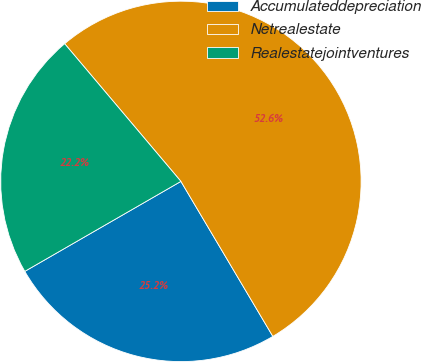Convert chart. <chart><loc_0><loc_0><loc_500><loc_500><pie_chart><fcel>Accumulateddepreciation<fcel>Netrealestate<fcel>Realestatejointventures<nl><fcel>25.2%<fcel>52.64%<fcel>22.16%<nl></chart> 